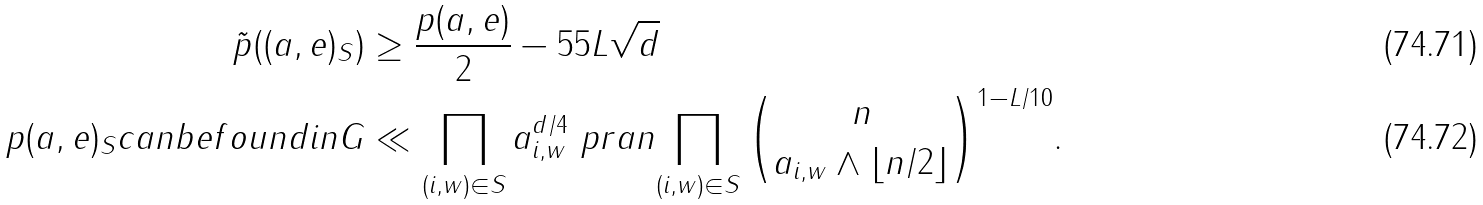<formula> <loc_0><loc_0><loc_500><loc_500>\tilde { p } ( ( { a } , { e } ) _ { S } ) & \geq \frac { p ( { a } , { e } ) } { 2 } - 5 5 L \sqrt { d } \\ \ p { ( { a } , { e } ) _ { S } c a n b e f o u n d i n G } & \ll \prod _ { ( i , w ) \in S } a _ { i , w } ^ { d / 4 } \ p r a n { \prod _ { ( i , w ) \in S } { n \choose a _ { i , w } \wedge \lfloor n / 2 \rfloor } } ^ { 1 - L / 1 0 } .</formula> 